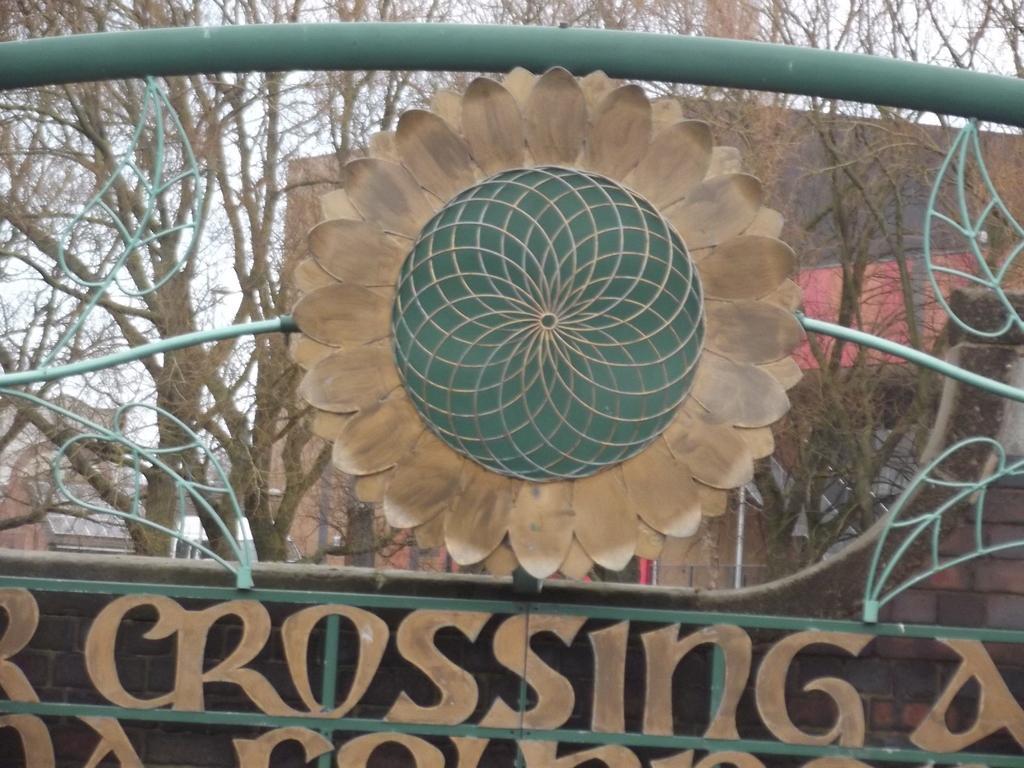Please provide a concise description of this image. In this image I can see the metal object which is in green and brown color. In the background I can see many trees, buildings and the sky. 